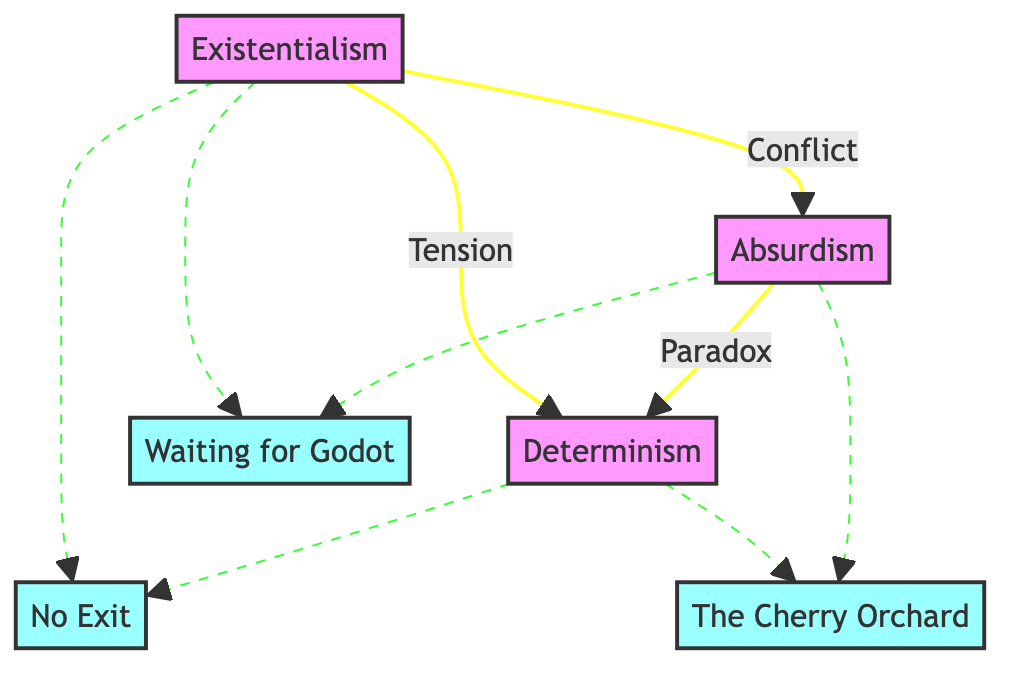What are the three philosophical themes represented in the diagram? The diagram clearly lists three blocks representing the major themes: Existentialism, Absurdism, and Determinism.
Answer: Existentialism, Absurdism, Determinism How many interactions are depicted in the diagram? By examining the interactions between the blocks, I see there are three interactions: Conflict, Tension, and Paradox. Therefore, the total number of interactions is three.
Answer: 3 What is the relationship between Existentialism and Absurdism? The diagram indicates a direct line labeled 'Conflict' that connects Existentialism to Absurdism, representing their relationship clearly.
Answer: Conflict Which play is associated with both Existentialism and Absurdism? The diagram illustrates that 'Waiting for Godot' is connected, represented with dashed lines to both Existentialism and Absurdism, indicating its association with both themes.
Answer: Waiting for Godot What type of relationship exists between Absurdism and Determinism? The diagram shows a connection labeled 'Paradox' between Absurdism and Determinism, indicating that the nature of their relationship reflects a paradoxical situation.
Answer: Paradox Which play represents the themes of Determinism and Absurdism? The diagram shows that 'The Cherry Orchard' is linked to both Determinism and Absurdism via dashed lines, indicating it embodies both themes.
Answer: The Cherry Orchard 